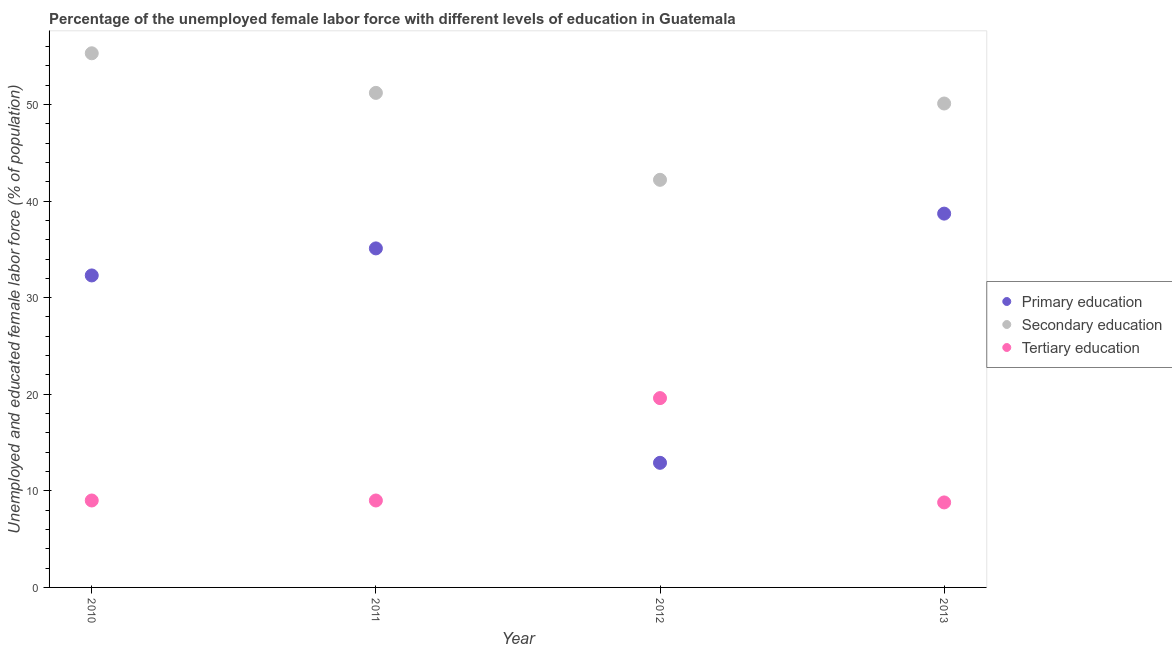What is the percentage of female labor force who received primary education in 2012?
Your answer should be very brief. 12.9. Across all years, what is the maximum percentage of female labor force who received tertiary education?
Keep it short and to the point. 19.6. Across all years, what is the minimum percentage of female labor force who received secondary education?
Ensure brevity in your answer.  42.2. In which year was the percentage of female labor force who received primary education minimum?
Offer a very short reply. 2012. What is the total percentage of female labor force who received primary education in the graph?
Provide a succinct answer. 119. What is the difference between the percentage of female labor force who received secondary education in 2010 and that in 2011?
Your answer should be compact. 4.1. What is the average percentage of female labor force who received primary education per year?
Provide a succinct answer. 29.75. In the year 2012, what is the difference between the percentage of female labor force who received tertiary education and percentage of female labor force who received primary education?
Your answer should be very brief. 6.7. What is the ratio of the percentage of female labor force who received tertiary education in 2011 to that in 2013?
Give a very brief answer. 1.02. Is the percentage of female labor force who received secondary education in 2011 less than that in 2012?
Keep it short and to the point. No. What is the difference between the highest and the second highest percentage of female labor force who received tertiary education?
Offer a terse response. 10.6. What is the difference between the highest and the lowest percentage of female labor force who received secondary education?
Provide a succinct answer. 13.1. In how many years, is the percentage of female labor force who received primary education greater than the average percentage of female labor force who received primary education taken over all years?
Give a very brief answer. 3. Is the sum of the percentage of female labor force who received secondary education in 2010 and 2011 greater than the maximum percentage of female labor force who received tertiary education across all years?
Ensure brevity in your answer.  Yes. Does the percentage of female labor force who received secondary education monotonically increase over the years?
Make the answer very short. No. What is the difference between two consecutive major ticks on the Y-axis?
Offer a very short reply. 10. Are the values on the major ticks of Y-axis written in scientific E-notation?
Ensure brevity in your answer.  No. Does the graph contain grids?
Make the answer very short. No. Where does the legend appear in the graph?
Ensure brevity in your answer.  Center right. How many legend labels are there?
Give a very brief answer. 3. How are the legend labels stacked?
Your answer should be compact. Vertical. What is the title of the graph?
Your answer should be very brief. Percentage of the unemployed female labor force with different levels of education in Guatemala. Does "Hydroelectric sources" appear as one of the legend labels in the graph?
Give a very brief answer. No. What is the label or title of the Y-axis?
Ensure brevity in your answer.  Unemployed and educated female labor force (% of population). What is the Unemployed and educated female labor force (% of population) of Primary education in 2010?
Make the answer very short. 32.3. What is the Unemployed and educated female labor force (% of population) in Secondary education in 2010?
Provide a short and direct response. 55.3. What is the Unemployed and educated female labor force (% of population) of Primary education in 2011?
Keep it short and to the point. 35.1. What is the Unemployed and educated female labor force (% of population) of Secondary education in 2011?
Offer a terse response. 51.2. What is the Unemployed and educated female labor force (% of population) of Primary education in 2012?
Keep it short and to the point. 12.9. What is the Unemployed and educated female labor force (% of population) in Secondary education in 2012?
Keep it short and to the point. 42.2. What is the Unemployed and educated female labor force (% of population) of Tertiary education in 2012?
Keep it short and to the point. 19.6. What is the Unemployed and educated female labor force (% of population) in Primary education in 2013?
Give a very brief answer. 38.7. What is the Unemployed and educated female labor force (% of population) of Secondary education in 2013?
Your answer should be compact. 50.1. What is the Unemployed and educated female labor force (% of population) of Tertiary education in 2013?
Your answer should be compact. 8.8. Across all years, what is the maximum Unemployed and educated female labor force (% of population) of Primary education?
Keep it short and to the point. 38.7. Across all years, what is the maximum Unemployed and educated female labor force (% of population) of Secondary education?
Make the answer very short. 55.3. Across all years, what is the maximum Unemployed and educated female labor force (% of population) in Tertiary education?
Give a very brief answer. 19.6. Across all years, what is the minimum Unemployed and educated female labor force (% of population) in Primary education?
Keep it short and to the point. 12.9. Across all years, what is the minimum Unemployed and educated female labor force (% of population) of Secondary education?
Provide a short and direct response. 42.2. Across all years, what is the minimum Unemployed and educated female labor force (% of population) of Tertiary education?
Ensure brevity in your answer.  8.8. What is the total Unemployed and educated female labor force (% of population) of Primary education in the graph?
Your answer should be compact. 119. What is the total Unemployed and educated female labor force (% of population) of Secondary education in the graph?
Give a very brief answer. 198.8. What is the total Unemployed and educated female labor force (% of population) in Tertiary education in the graph?
Offer a terse response. 46.4. What is the difference between the Unemployed and educated female labor force (% of population) in Primary education in 2010 and that in 2011?
Offer a very short reply. -2.8. What is the difference between the Unemployed and educated female labor force (% of population) in Tertiary education in 2010 and that in 2013?
Your response must be concise. 0.2. What is the difference between the Unemployed and educated female labor force (% of population) in Primary education in 2011 and that in 2012?
Keep it short and to the point. 22.2. What is the difference between the Unemployed and educated female labor force (% of population) in Secondary education in 2011 and that in 2012?
Provide a succinct answer. 9. What is the difference between the Unemployed and educated female labor force (% of population) in Secondary education in 2011 and that in 2013?
Provide a short and direct response. 1.1. What is the difference between the Unemployed and educated female labor force (% of population) of Tertiary education in 2011 and that in 2013?
Your answer should be very brief. 0.2. What is the difference between the Unemployed and educated female labor force (% of population) of Primary education in 2012 and that in 2013?
Give a very brief answer. -25.8. What is the difference between the Unemployed and educated female labor force (% of population) in Secondary education in 2012 and that in 2013?
Your answer should be compact. -7.9. What is the difference between the Unemployed and educated female labor force (% of population) of Primary education in 2010 and the Unemployed and educated female labor force (% of population) of Secondary education in 2011?
Offer a very short reply. -18.9. What is the difference between the Unemployed and educated female labor force (% of population) of Primary education in 2010 and the Unemployed and educated female labor force (% of population) of Tertiary education in 2011?
Ensure brevity in your answer.  23.3. What is the difference between the Unemployed and educated female labor force (% of population) of Secondary education in 2010 and the Unemployed and educated female labor force (% of population) of Tertiary education in 2011?
Give a very brief answer. 46.3. What is the difference between the Unemployed and educated female labor force (% of population) in Primary education in 2010 and the Unemployed and educated female labor force (% of population) in Secondary education in 2012?
Give a very brief answer. -9.9. What is the difference between the Unemployed and educated female labor force (% of population) in Primary education in 2010 and the Unemployed and educated female labor force (% of population) in Tertiary education in 2012?
Make the answer very short. 12.7. What is the difference between the Unemployed and educated female labor force (% of population) of Secondary education in 2010 and the Unemployed and educated female labor force (% of population) of Tertiary education in 2012?
Make the answer very short. 35.7. What is the difference between the Unemployed and educated female labor force (% of population) in Primary education in 2010 and the Unemployed and educated female labor force (% of population) in Secondary education in 2013?
Provide a short and direct response. -17.8. What is the difference between the Unemployed and educated female labor force (% of population) in Secondary education in 2010 and the Unemployed and educated female labor force (% of population) in Tertiary education in 2013?
Offer a terse response. 46.5. What is the difference between the Unemployed and educated female labor force (% of population) in Primary education in 2011 and the Unemployed and educated female labor force (% of population) in Tertiary education in 2012?
Keep it short and to the point. 15.5. What is the difference between the Unemployed and educated female labor force (% of population) in Secondary education in 2011 and the Unemployed and educated female labor force (% of population) in Tertiary education in 2012?
Give a very brief answer. 31.6. What is the difference between the Unemployed and educated female labor force (% of population) in Primary education in 2011 and the Unemployed and educated female labor force (% of population) in Tertiary education in 2013?
Provide a succinct answer. 26.3. What is the difference between the Unemployed and educated female labor force (% of population) in Secondary education in 2011 and the Unemployed and educated female labor force (% of population) in Tertiary education in 2013?
Offer a terse response. 42.4. What is the difference between the Unemployed and educated female labor force (% of population) in Primary education in 2012 and the Unemployed and educated female labor force (% of population) in Secondary education in 2013?
Your response must be concise. -37.2. What is the difference between the Unemployed and educated female labor force (% of population) in Secondary education in 2012 and the Unemployed and educated female labor force (% of population) in Tertiary education in 2013?
Give a very brief answer. 33.4. What is the average Unemployed and educated female labor force (% of population) in Primary education per year?
Give a very brief answer. 29.75. What is the average Unemployed and educated female labor force (% of population) of Secondary education per year?
Ensure brevity in your answer.  49.7. What is the average Unemployed and educated female labor force (% of population) in Tertiary education per year?
Offer a very short reply. 11.6. In the year 2010, what is the difference between the Unemployed and educated female labor force (% of population) of Primary education and Unemployed and educated female labor force (% of population) of Secondary education?
Offer a terse response. -23. In the year 2010, what is the difference between the Unemployed and educated female labor force (% of population) in Primary education and Unemployed and educated female labor force (% of population) in Tertiary education?
Offer a very short reply. 23.3. In the year 2010, what is the difference between the Unemployed and educated female labor force (% of population) of Secondary education and Unemployed and educated female labor force (% of population) of Tertiary education?
Make the answer very short. 46.3. In the year 2011, what is the difference between the Unemployed and educated female labor force (% of population) in Primary education and Unemployed and educated female labor force (% of population) in Secondary education?
Give a very brief answer. -16.1. In the year 2011, what is the difference between the Unemployed and educated female labor force (% of population) in Primary education and Unemployed and educated female labor force (% of population) in Tertiary education?
Your answer should be compact. 26.1. In the year 2011, what is the difference between the Unemployed and educated female labor force (% of population) of Secondary education and Unemployed and educated female labor force (% of population) of Tertiary education?
Offer a terse response. 42.2. In the year 2012, what is the difference between the Unemployed and educated female labor force (% of population) in Primary education and Unemployed and educated female labor force (% of population) in Secondary education?
Keep it short and to the point. -29.3. In the year 2012, what is the difference between the Unemployed and educated female labor force (% of population) of Secondary education and Unemployed and educated female labor force (% of population) of Tertiary education?
Provide a short and direct response. 22.6. In the year 2013, what is the difference between the Unemployed and educated female labor force (% of population) in Primary education and Unemployed and educated female labor force (% of population) in Tertiary education?
Give a very brief answer. 29.9. In the year 2013, what is the difference between the Unemployed and educated female labor force (% of population) in Secondary education and Unemployed and educated female labor force (% of population) in Tertiary education?
Ensure brevity in your answer.  41.3. What is the ratio of the Unemployed and educated female labor force (% of population) in Primary education in 2010 to that in 2011?
Offer a very short reply. 0.92. What is the ratio of the Unemployed and educated female labor force (% of population) in Secondary education in 2010 to that in 2011?
Keep it short and to the point. 1.08. What is the ratio of the Unemployed and educated female labor force (% of population) in Tertiary education in 2010 to that in 2011?
Offer a very short reply. 1. What is the ratio of the Unemployed and educated female labor force (% of population) in Primary education in 2010 to that in 2012?
Ensure brevity in your answer.  2.5. What is the ratio of the Unemployed and educated female labor force (% of population) of Secondary education in 2010 to that in 2012?
Provide a short and direct response. 1.31. What is the ratio of the Unemployed and educated female labor force (% of population) of Tertiary education in 2010 to that in 2012?
Offer a terse response. 0.46. What is the ratio of the Unemployed and educated female labor force (% of population) in Primary education in 2010 to that in 2013?
Your response must be concise. 0.83. What is the ratio of the Unemployed and educated female labor force (% of population) in Secondary education in 2010 to that in 2013?
Provide a short and direct response. 1.1. What is the ratio of the Unemployed and educated female labor force (% of population) in Tertiary education in 2010 to that in 2013?
Provide a succinct answer. 1.02. What is the ratio of the Unemployed and educated female labor force (% of population) of Primary education in 2011 to that in 2012?
Offer a very short reply. 2.72. What is the ratio of the Unemployed and educated female labor force (% of population) in Secondary education in 2011 to that in 2012?
Offer a terse response. 1.21. What is the ratio of the Unemployed and educated female labor force (% of population) of Tertiary education in 2011 to that in 2012?
Keep it short and to the point. 0.46. What is the ratio of the Unemployed and educated female labor force (% of population) of Primary education in 2011 to that in 2013?
Offer a very short reply. 0.91. What is the ratio of the Unemployed and educated female labor force (% of population) in Secondary education in 2011 to that in 2013?
Make the answer very short. 1.02. What is the ratio of the Unemployed and educated female labor force (% of population) in Tertiary education in 2011 to that in 2013?
Provide a succinct answer. 1.02. What is the ratio of the Unemployed and educated female labor force (% of population) of Primary education in 2012 to that in 2013?
Make the answer very short. 0.33. What is the ratio of the Unemployed and educated female labor force (% of population) in Secondary education in 2012 to that in 2013?
Make the answer very short. 0.84. What is the ratio of the Unemployed and educated female labor force (% of population) in Tertiary education in 2012 to that in 2013?
Make the answer very short. 2.23. What is the difference between the highest and the second highest Unemployed and educated female labor force (% of population) of Secondary education?
Give a very brief answer. 4.1. What is the difference between the highest and the second highest Unemployed and educated female labor force (% of population) in Tertiary education?
Offer a terse response. 10.6. What is the difference between the highest and the lowest Unemployed and educated female labor force (% of population) of Primary education?
Provide a succinct answer. 25.8. What is the difference between the highest and the lowest Unemployed and educated female labor force (% of population) of Secondary education?
Offer a very short reply. 13.1. What is the difference between the highest and the lowest Unemployed and educated female labor force (% of population) in Tertiary education?
Offer a very short reply. 10.8. 